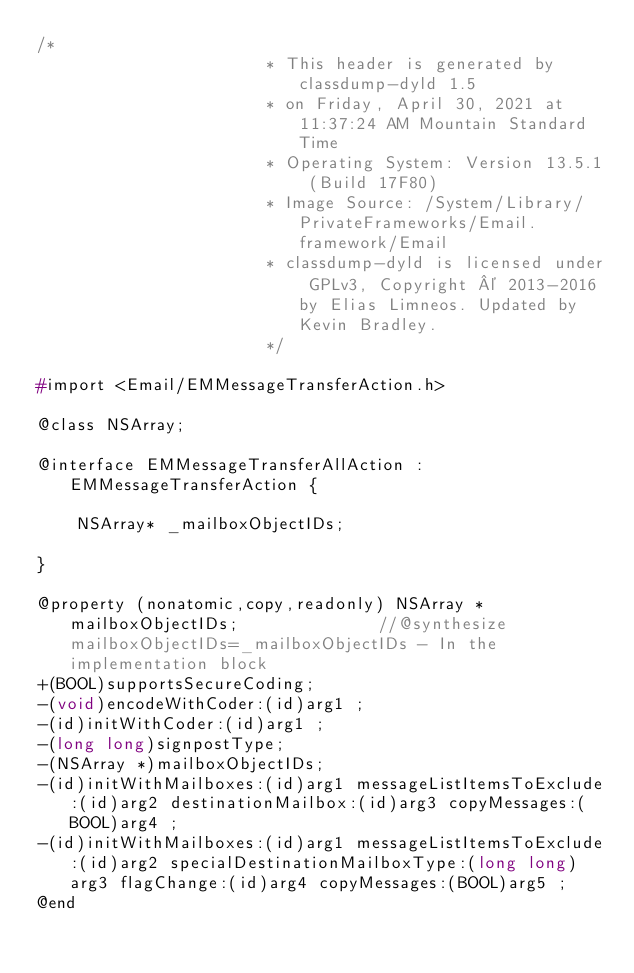Convert code to text. <code><loc_0><loc_0><loc_500><loc_500><_C_>/*
                       * This header is generated by classdump-dyld 1.5
                       * on Friday, April 30, 2021 at 11:37:24 AM Mountain Standard Time
                       * Operating System: Version 13.5.1 (Build 17F80)
                       * Image Source: /System/Library/PrivateFrameworks/Email.framework/Email
                       * classdump-dyld is licensed under GPLv3, Copyright © 2013-2016 by Elias Limneos. Updated by Kevin Bradley.
                       */

#import <Email/EMMessageTransferAction.h>

@class NSArray;

@interface EMMessageTransferAllAction : EMMessageTransferAction {

	NSArray* _mailboxObjectIDs;

}

@property (nonatomic,copy,readonly) NSArray * mailboxObjectIDs;              //@synthesize mailboxObjectIDs=_mailboxObjectIDs - In the implementation block
+(BOOL)supportsSecureCoding;
-(void)encodeWithCoder:(id)arg1 ;
-(id)initWithCoder:(id)arg1 ;
-(long long)signpostType;
-(NSArray *)mailboxObjectIDs;
-(id)initWithMailboxes:(id)arg1 messageListItemsToExclude:(id)arg2 destinationMailbox:(id)arg3 copyMessages:(BOOL)arg4 ;
-(id)initWithMailboxes:(id)arg1 messageListItemsToExclude:(id)arg2 specialDestinationMailboxType:(long long)arg3 flagChange:(id)arg4 copyMessages:(BOOL)arg5 ;
@end

</code> 